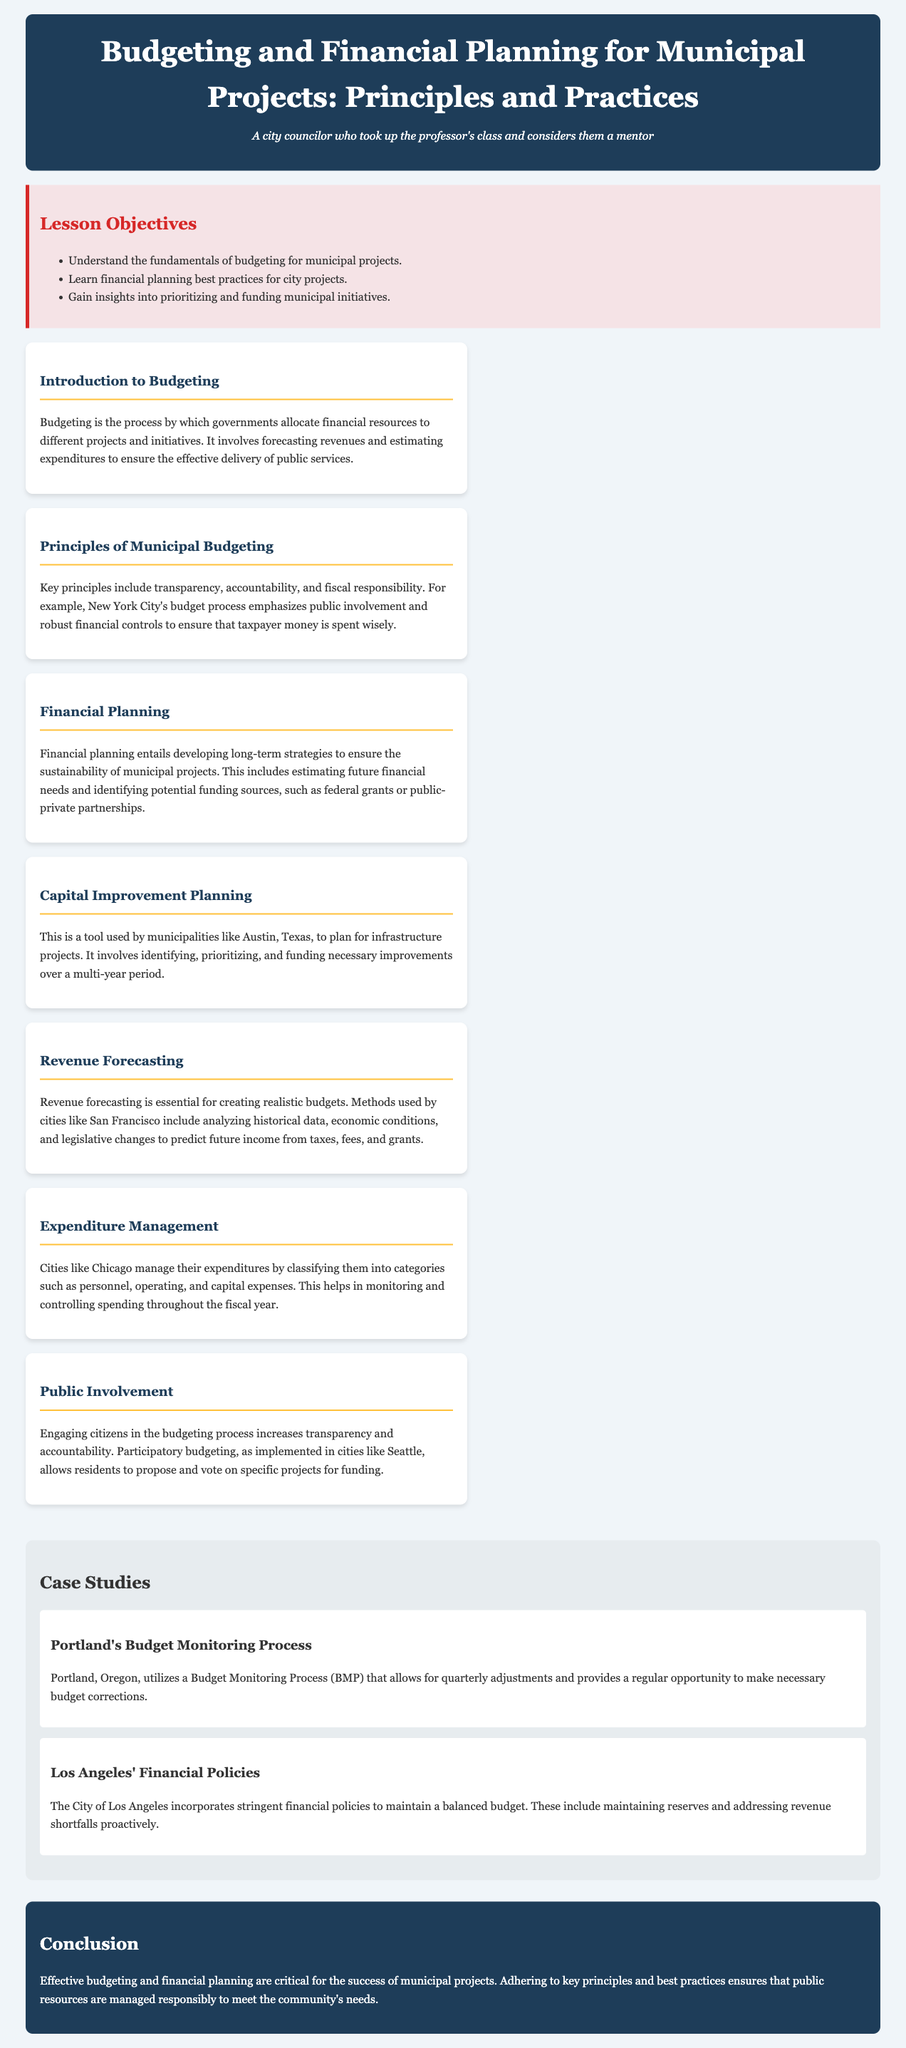What are the lesson objectives? The lesson objectives are outlined in the document's objectives section, focusing on key learning goals for participants.
Answer: Understand the fundamentals of budgeting for municipal projects; Learn financial planning best practices for city projects; Gain insights into prioritizing and funding municipal initiatives What is the first topic discussed in the document? The document introduces specific topics related to budgeting and financial planning, starting with the first topic.
Answer: Introduction to Budgeting What city's budgeting process emphasizes public involvement? The document provides examples of cities that demonstrate specific budgeting practices, including one that highlights public engagement.
Answer: New York City Which city uses a Budget Monitoring Process? A case study in the document describes how a particular city implements a monitoring process for its budget.
Answer: Portland What financial planning practice is mentioned in the case studies? The case studies section focuses on real-world examples of financial practices; one city's specific practice is highlighted regarding balance.
Answer: Financial Policies What are two key principles of municipal budgeting? The principles are discussed in the context of best practices for budgeting in municipal settings.
Answer: Transparency, Accountability In what city is participatory budgeting implemented? The document references a specific city implementing participatory budgeting to engage citizens.
Answer: Seattle What does capital improvement planning help to plan? This topic is covered under financial planning strategies, focusing on the management of infrastructure.
Answer: Infrastructure projects 